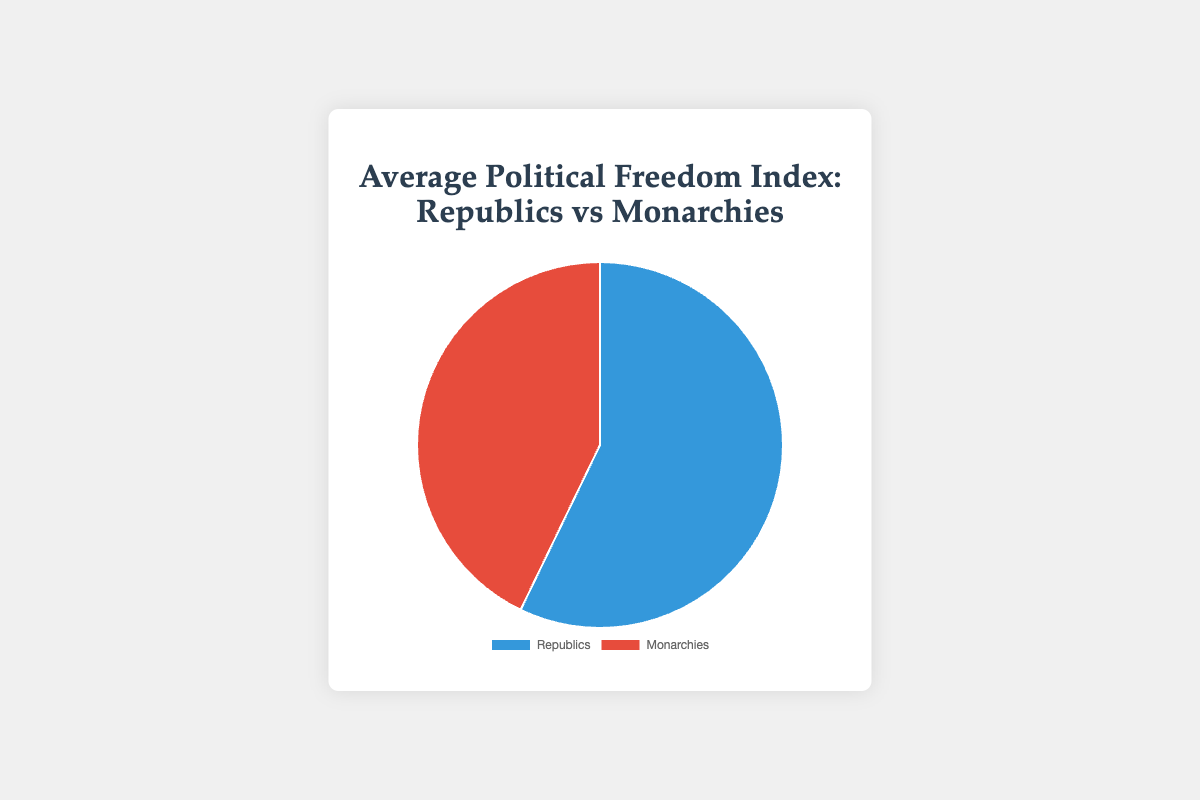What are the different political freedom indices for Republics in the dataset? Refer to the indices listed under Republics in the data. The countries and their indices are: United States (83), Germany (84), India (77), Brazil (70), and South Korea (78).
Answer: 83, 84, 77, 70, 78 What is the average political freedom index for Monarchies? According to the data, the average political freedom index for Monarchies is 58.8. This is likely calculated from the individual indices: United Kingdom (79), Sweden (88), Japan (82), Saudi Arabia (7), Morocco (38). Sum these indices (79 + 88 + 82 + 7 + 38 = 294) and divide by the number of countries (5) to get 58.8.
Answer: 58.8 How much higher is the average political freedom index of Republics compared to Monarchies? The average political freedom index for Republics is 78.4 and for Monarchies it is 58.8. Subtract these values to find the difference: 78.4 - 58.8 = 19.6.
Answer: 19.6 Which political system has the higher average political freedom index according to the pie chart? The pie chart shows that Republics have a higher average political freedom index (78.4) compared to Monarchies (58.8).
Answer: Republics Visually, which category has a larger area on the pie chart, Republics or Monarchies? The pie chart visually represents Republics with a larger area, indicating a higher average political freedom index (78.4) as compared to Monarchies (58.8).
Answer: Republics Which country among the republics has the highest political freedom index? Among the republics, data lists Germany with the highest political freedom index of 84.
Answer: Germany Name the country with the lowest political freedom index among the monarchies, and what is its value? Among the monarchies, Saudi Arabia has the lowest political freedom index, which is 7.
Answer: Saudi Arabia, 7 Considering the color representation in the pie chart, which color represents Monarchies? In the pie chart, Monarchies are represented by the red color.
Answer: Red How many more points is the highest political freedom index in a monarchy compared to the lowest? The highest index in a monarchy is Sweden's 88, and the lowest is Saudi Arabia's 7. The difference is 88 - 7 = 81.
Answer: 81 Across both Republics and Monarchies, which has a wider range of political freedom indices? To find the range for each, for Republics: max is 84 (Germany) and min is 70 (Brazil), range = 84 - 70 = 14. For Monarchies: max is 88 (Sweden) and min is 7 (Saudi Arabia), range = 88 - 7 = 81. Monarchies have a wider range.
Answer: Monarchies 